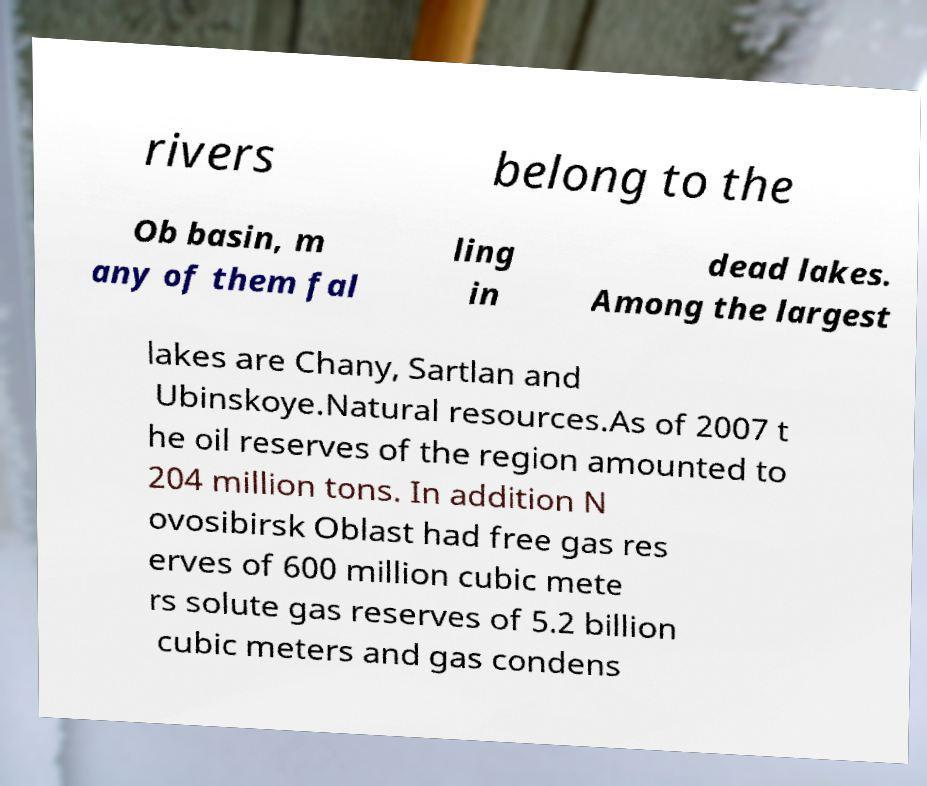Could you assist in decoding the text presented in this image and type it out clearly? rivers belong to the Ob basin, m any of them fal ling in dead lakes. Among the largest lakes are Chany, Sartlan and Ubinskoye.Natural resources.As of 2007 t he oil reserves of the region amounted to 204 million tons. In addition N ovosibirsk Oblast had free gas res erves of 600 million cubic mete rs solute gas reserves of 5.2 billion cubic meters and gas condens 